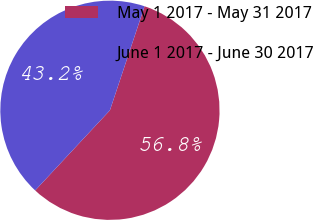Convert chart. <chart><loc_0><loc_0><loc_500><loc_500><pie_chart><fcel>May 1 2017 - May 31 2017<fcel>June 1 2017 - June 30 2017<nl><fcel>56.83%<fcel>43.17%<nl></chart> 